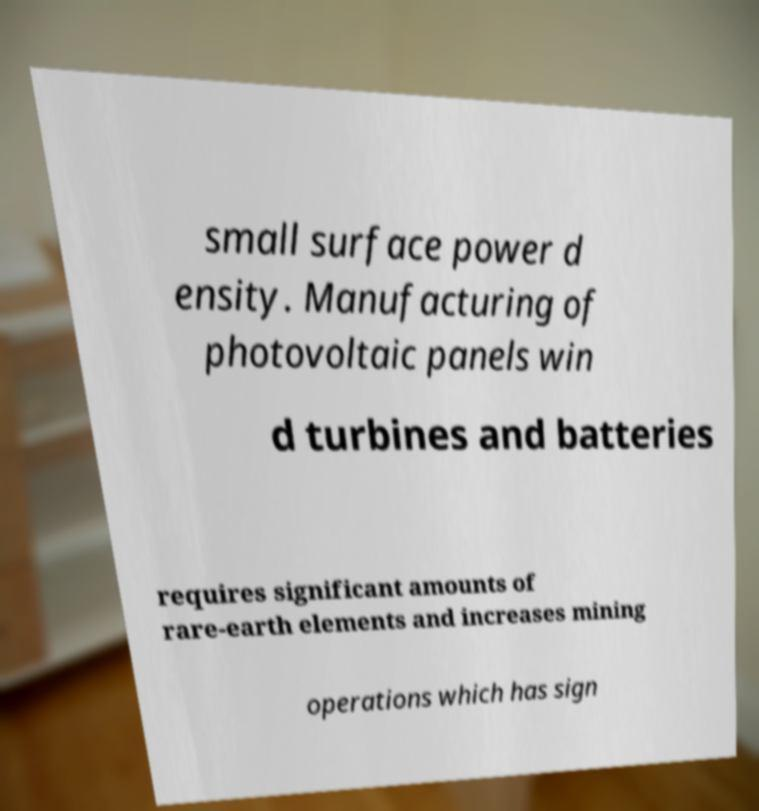Please read and relay the text visible in this image. What does it say? small surface power d ensity. Manufacturing of photovoltaic panels win d turbines and batteries requires significant amounts of rare-earth elements and increases mining operations which has sign 